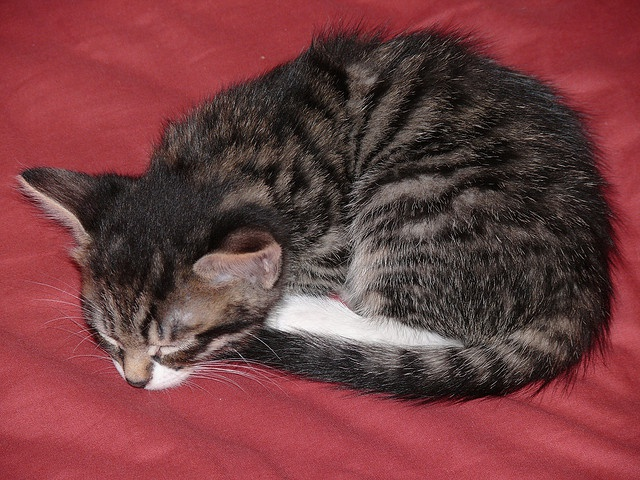Describe the objects in this image and their specific colors. I can see bed in black, brown, and gray tones and cat in maroon, black, gray, and brown tones in this image. 